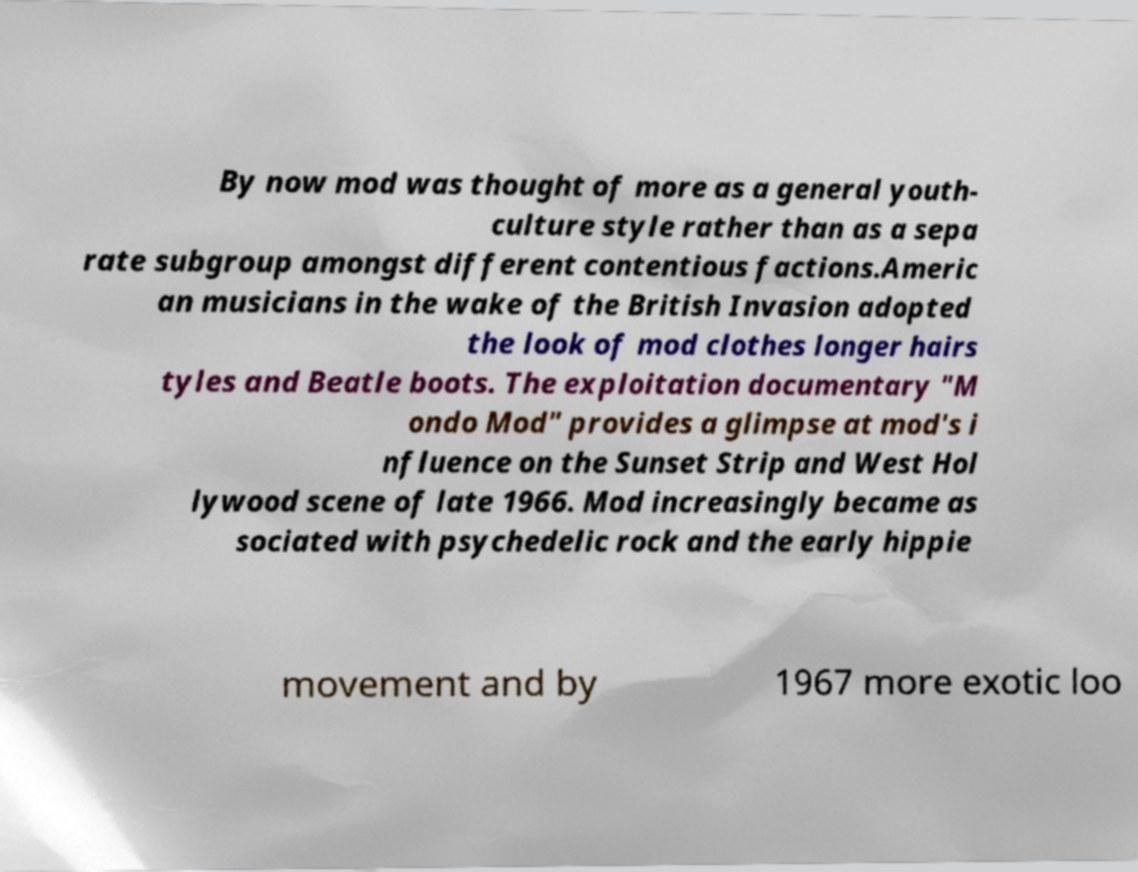Please identify and transcribe the text found in this image. By now mod was thought of more as a general youth- culture style rather than as a sepa rate subgroup amongst different contentious factions.Americ an musicians in the wake of the British Invasion adopted the look of mod clothes longer hairs tyles and Beatle boots. The exploitation documentary "M ondo Mod" provides a glimpse at mod's i nfluence on the Sunset Strip and West Hol lywood scene of late 1966. Mod increasingly became as sociated with psychedelic rock and the early hippie movement and by 1967 more exotic loo 